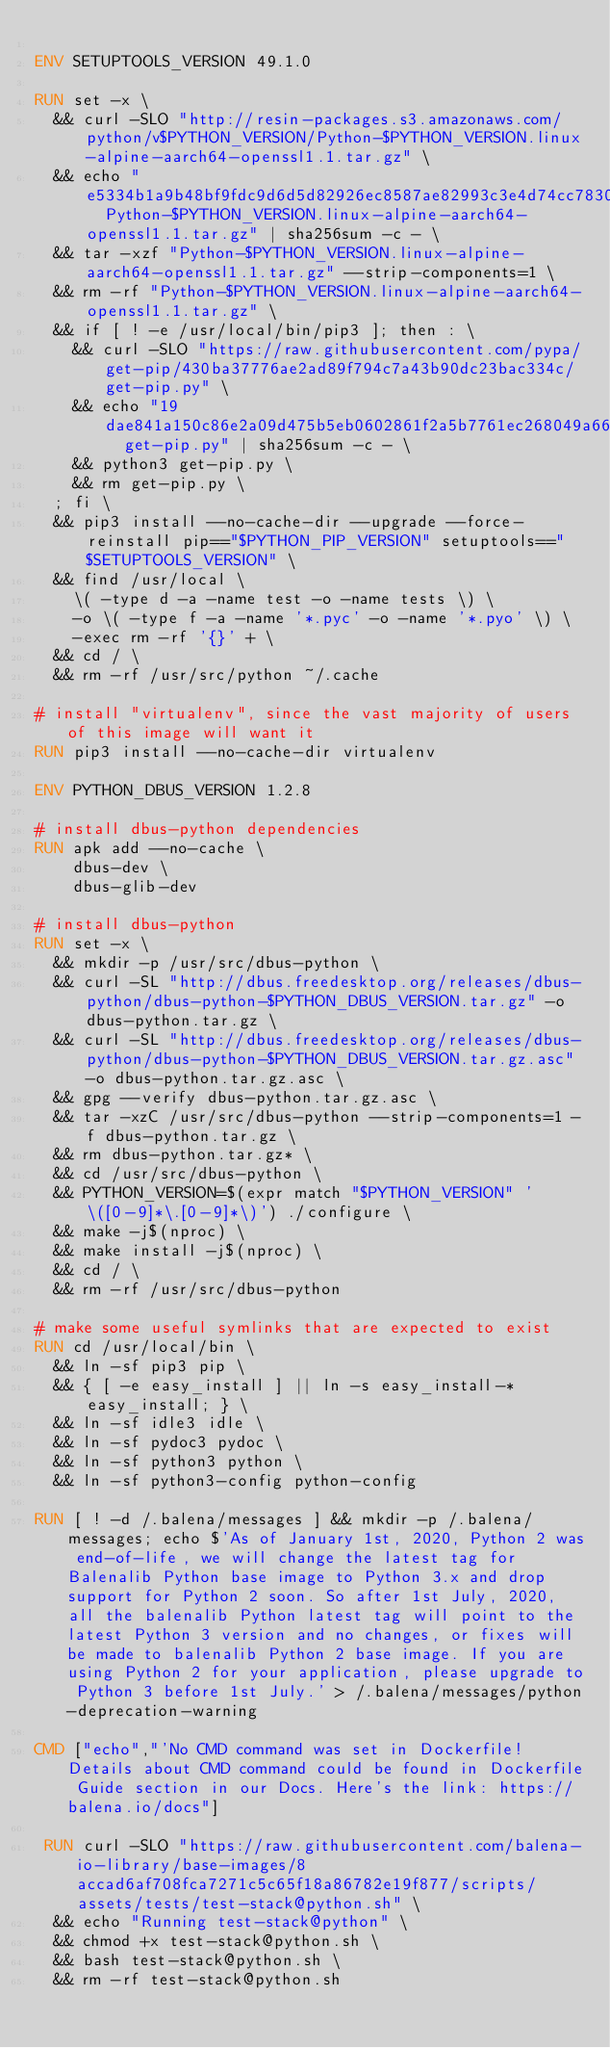Convert code to text. <code><loc_0><loc_0><loc_500><loc_500><_Dockerfile_>
ENV SETUPTOOLS_VERSION 49.1.0

RUN set -x \
	&& curl -SLO "http://resin-packages.s3.amazonaws.com/python/v$PYTHON_VERSION/Python-$PYTHON_VERSION.linux-alpine-aarch64-openssl1.1.tar.gz" \
	&& echo "e5334b1a9b48bf9fdc9d6d5d82926ec8587ae82993c3e4d74cc78306d7fadc39  Python-$PYTHON_VERSION.linux-alpine-aarch64-openssl1.1.tar.gz" | sha256sum -c - \
	&& tar -xzf "Python-$PYTHON_VERSION.linux-alpine-aarch64-openssl1.1.tar.gz" --strip-components=1 \
	&& rm -rf "Python-$PYTHON_VERSION.linux-alpine-aarch64-openssl1.1.tar.gz" \
	&& if [ ! -e /usr/local/bin/pip3 ]; then : \
		&& curl -SLO "https://raw.githubusercontent.com/pypa/get-pip/430ba37776ae2ad89f794c7a43b90dc23bac334c/get-pip.py" \
		&& echo "19dae841a150c86e2a09d475b5eb0602861f2a5b7761ec268049a662dbd2bd0c  get-pip.py" | sha256sum -c - \
		&& python3 get-pip.py \
		&& rm get-pip.py \
	; fi \
	&& pip3 install --no-cache-dir --upgrade --force-reinstall pip=="$PYTHON_PIP_VERSION" setuptools=="$SETUPTOOLS_VERSION" \
	&& find /usr/local \
		\( -type d -a -name test -o -name tests \) \
		-o \( -type f -a -name '*.pyc' -o -name '*.pyo' \) \
		-exec rm -rf '{}' + \
	&& cd / \
	&& rm -rf /usr/src/python ~/.cache

# install "virtualenv", since the vast majority of users of this image will want it
RUN pip3 install --no-cache-dir virtualenv

ENV PYTHON_DBUS_VERSION 1.2.8

# install dbus-python dependencies 
RUN apk add --no-cache \
		dbus-dev \
		dbus-glib-dev

# install dbus-python
RUN set -x \
	&& mkdir -p /usr/src/dbus-python \
	&& curl -SL "http://dbus.freedesktop.org/releases/dbus-python/dbus-python-$PYTHON_DBUS_VERSION.tar.gz" -o dbus-python.tar.gz \
	&& curl -SL "http://dbus.freedesktop.org/releases/dbus-python/dbus-python-$PYTHON_DBUS_VERSION.tar.gz.asc" -o dbus-python.tar.gz.asc \
	&& gpg --verify dbus-python.tar.gz.asc \
	&& tar -xzC /usr/src/dbus-python --strip-components=1 -f dbus-python.tar.gz \
	&& rm dbus-python.tar.gz* \
	&& cd /usr/src/dbus-python \
	&& PYTHON_VERSION=$(expr match "$PYTHON_VERSION" '\([0-9]*\.[0-9]*\)') ./configure \
	&& make -j$(nproc) \
	&& make install -j$(nproc) \
	&& cd / \
	&& rm -rf /usr/src/dbus-python

# make some useful symlinks that are expected to exist
RUN cd /usr/local/bin \
	&& ln -sf pip3 pip \
	&& { [ -e easy_install ] || ln -s easy_install-* easy_install; } \
	&& ln -sf idle3 idle \
	&& ln -sf pydoc3 pydoc \
	&& ln -sf python3 python \
	&& ln -sf python3-config python-config

RUN [ ! -d /.balena/messages ] && mkdir -p /.balena/messages; echo $'As of January 1st, 2020, Python 2 was end-of-life, we will change the latest tag for Balenalib Python base image to Python 3.x and drop support for Python 2 soon. So after 1st July, 2020, all the balenalib Python latest tag will point to the latest Python 3 version and no changes, or fixes will be made to balenalib Python 2 base image. If you are using Python 2 for your application, please upgrade to Python 3 before 1st July.' > /.balena/messages/python-deprecation-warning

CMD ["echo","'No CMD command was set in Dockerfile! Details about CMD command could be found in Dockerfile Guide section in our Docs. Here's the link: https://balena.io/docs"]

 RUN curl -SLO "https://raw.githubusercontent.com/balena-io-library/base-images/8accad6af708fca7271c5c65f18a86782e19f877/scripts/assets/tests/test-stack@python.sh" \
  && echo "Running test-stack@python" \
  && chmod +x test-stack@python.sh \
  && bash test-stack@python.sh \
  && rm -rf test-stack@python.sh 
</code> 